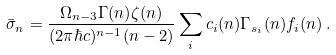Convert formula to latex. <formula><loc_0><loc_0><loc_500><loc_500>\bar { \sigma } _ { n } = \frac { \Omega _ { n - 3 } \Gamma ( n ) \zeta ( n ) } { ( 2 \pi \hbar { c } ) ^ { n - 1 } ( n - 2 ) } \sum _ { i } c _ { i } ( n ) \Gamma _ { s _ { i } } ( n ) f _ { i } ( n ) \, .</formula> 